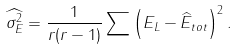Convert formula to latex. <formula><loc_0><loc_0><loc_500><loc_500>\widehat { \sigma _ { E } ^ { 2 } } = \frac { 1 } { r ( r - 1 ) } \sum \left ( E _ { L } - \widehat { E } _ { t o t } \right ) ^ { 2 } .</formula> 